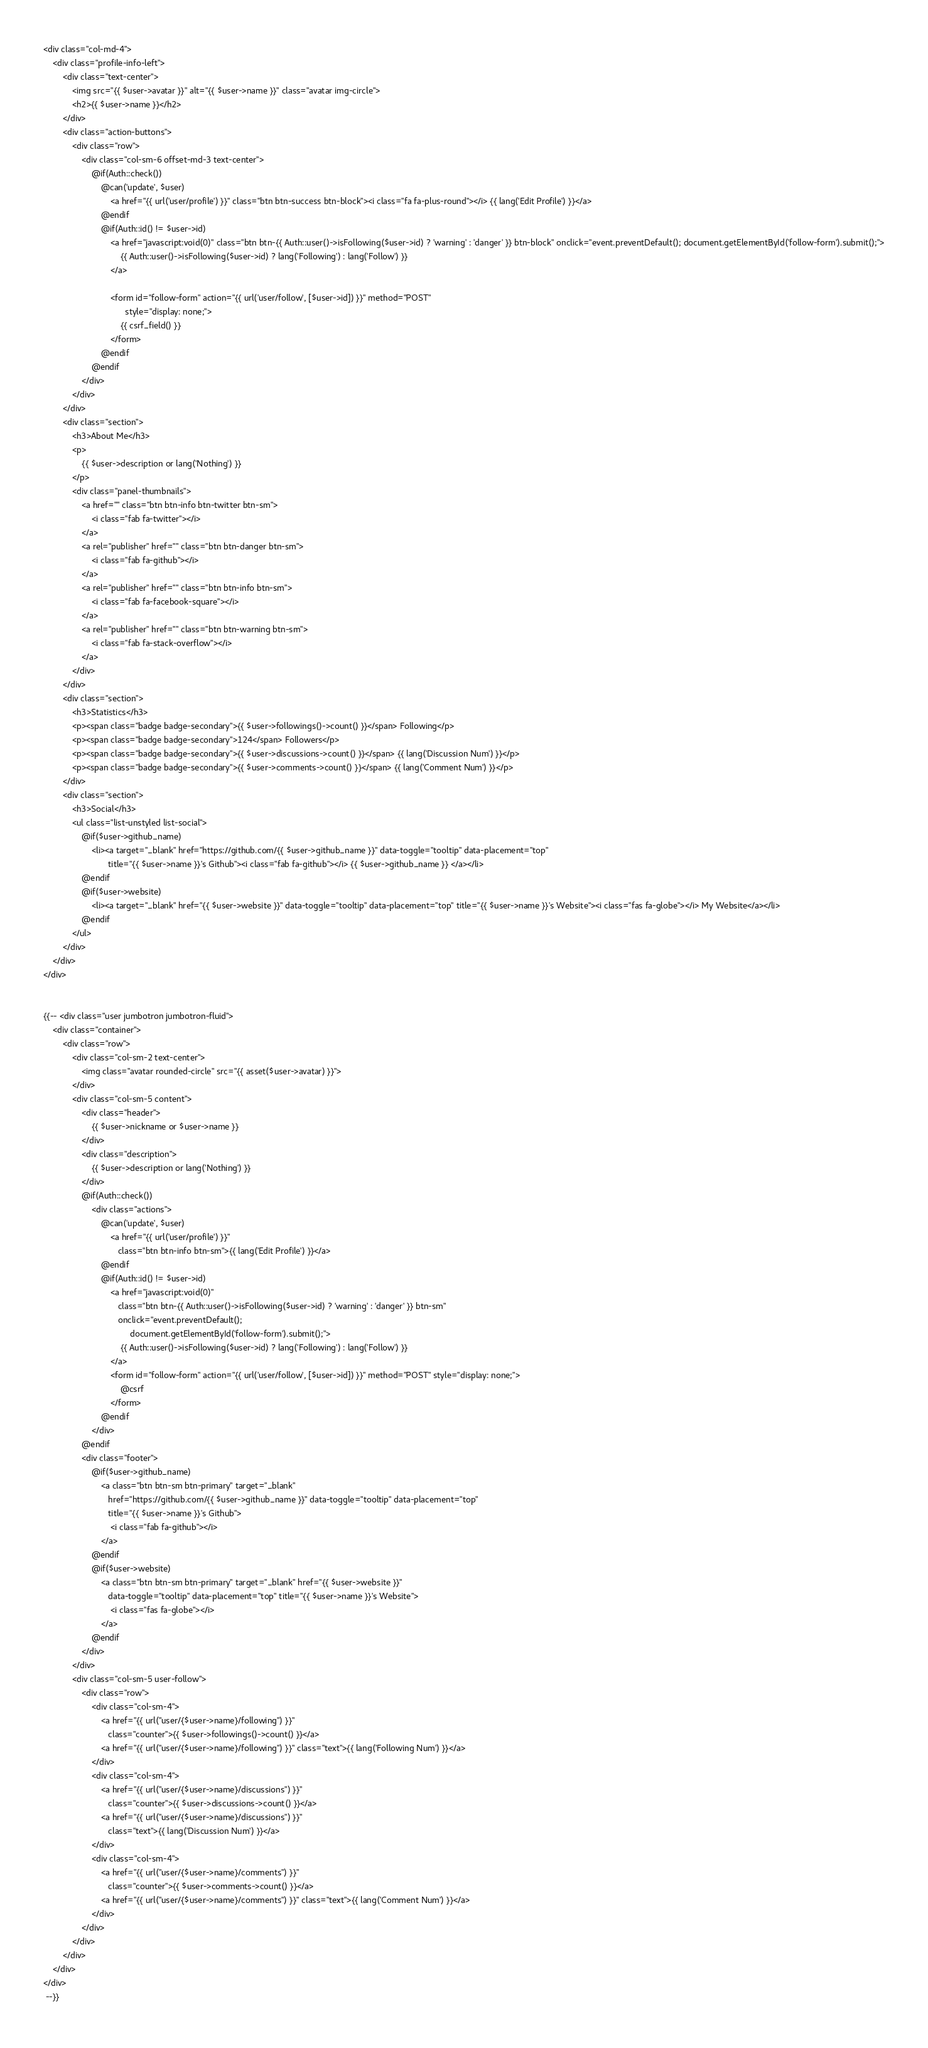<code> <loc_0><loc_0><loc_500><loc_500><_PHP_><div class="col-md-4">
    <div class="profile-info-left">
        <div class="text-center">
            <img src="{{ $user->avatar }}" alt="{{ $user->name }}" class="avatar img-circle">
            <h2>{{ $user->name }}</h2>
        </div>
        <div class="action-buttons">
            <div class="row">
                <div class="col-sm-6 offset-md-3 text-center">
                    @if(Auth::check())
                        @can('update', $user)
                            <a href="{{ url('user/profile') }}" class="btn btn-success btn-block"><i class="fa fa-plus-round"></i> {{ lang('Edit Profile') }}</a>
                        @endif
                        @if(Auth::id() != $user->id)
                            <a href="javascript:void(0)" class="btn btn-{{ Auth::user()->isFollowing($user->id) ? 'warning' : 'danger' }} btn-block" onclick="event.preventDefault(); document.getElementById('follow-form').submit();">
                                {{ Auth::user()->isFollowing($user->id) ? lang('Following') : lang('Follow') }}
                            </a>

                            <form id="follow-form" action="{{ url('user/follow', [$user->id]) }}" method="POST"
                                  style="display: none;">
                                {{ csrf_field() }}
                            </form>
                        @endif
                    @endif
                </div>
            </div>
        </div>
        <div class="section">
            <h3>About Me</h3>
            <p>
                {{ $user->description or lang('Nothing') }}
            </p>
            <div class="panel-thumbnails">
                <a href="" class="btn btn-info btn-twitter btn-sm">
                    <i class="fab fa-twitter"></i>
                </a>
                <a rel="publisher" href="" class="btn btn-danger btn-sm">
                    <i class="fab fa-github"></i>
                </a>
                <a rel="publisher" href="" class="btn btn-info btn-sm">
                    <i class="fab fa-facebook-square"></i>
                </a>
                <a rel="publisher" href="" class="btn btn-warning btn-sm">
                    <i class="fab fa-stack-overflow"></i>
                </a>
            </div>
        </div>
        <div class="section">
            <h3>Statistics</h3>
            <p><span class="badge badge-secondary">{{ $user->followings()->count() }}</span> Following</p>
            <p><span class="badge badge-secondary">124</span> Followers</p>
            <p><span class="badge badge-secondary">{{ $user->discussions->count() }}</span> {{ lang('Discussion Num') }}</p>
            <p><span class="badge badge-secondary">{{ $user->comments->count() }}</span> {{ lang('Comment Num') }}</p>
        </div>
        <div class="section">
            <h3>Social</h3>
            <ul class="list-unstyled list-social">
                @if($user->github_name)
                    <li><a target="_blank" href="https://github.com/{{ $user->github_name }}" data-toggle="tooltip" data-placement="top"
                           title="{{ $user->name }}'s Github"><i class="fab fa-github"></i> {{ $user->github_name }} </a></li>
                @endif
                @if($user->website)
                    <li><a target="_blank" href="{{ $user->website }}" data-toggle="tooltip" data-placement="top" title="{{ $user->name }}'s Website"><i class="fas fa-globe"></i> My Website</a></li>
                @endif
            </ul>
        </div>
    </div>
</div>


{{-- <div class="user jumbotron jumbotron-fluid">
    <div class="container">
        <div class="row">
            <div class="col-sm-2 text-center">
                <img class="avatar rounded-circle" src="{{ asset($user->avatar) }}">
            </div>
            <div class="col-sm-5 content">
                <div class="header">
                    {{ $user->nickname or $user->name }}
                </div>
                <div class="description">
                    {{ $user->description or lang('Nothing') }}
                </div>
                @if(Auth::check())
                    <div class="actions">
                        @can('update', $user)
                            <a href="{{ url('user/profile') }}"
                               class="btn btn-info btn-sm">{{ lang('Edit Profile') }}</a>
                        @endif
                        @if(Auth::id() != $user->id)
                            <a href="javascript:void(0)"
                               class="btn btn-{{ Auth::user()->isFollowing($user->id) ? 'warning' : 'danger' }} btn-sm"
                               onclick="event.preventDefault();
                                    document.getElementById('follow-form').submit();">
                                {{ Auth::user()->isFollowing($user->id) ? lang('Following') : lang('Follow') }}
                            </a>
                            <form id="follow-form" action="{{ url('user/follow', [$user->id]) }}" method="POST" style="display: none;">
                                @csrf
                            </form>
                        @endif
                    </div>
                @endif
                <div class="footer">
                    @if($user->github_name)
                        <a class="btn btn-sm btn-primary" target="_blank"
                           href="https://github.com/{{ $user->github_name }}" data-toggle="tooltip" data-placement="top"
                           title="{{ $user->name }}'s Github">
                            <i class="fab fa-github"></i>
                        </a>
                    @endif
                    @if($user->website)
                        <a class="btn btn-sm btn-primary" target="_blank" href="{{ $user->website }}"
                           data-toggle="tooltip" data-placement="top" title="{{ $user->name }}'s Website">
                            <i class="fas fa-globe"></i>
                        </a>
                    @endif
                </div>
            </div>
            <div class="col-sm-5 user-follow">
                <div class="row">
                    <div class="col-sm-4">
                        <a href="{{ url("user/{$user->name}/following") }}"
                           class="counter">{{ $user->followings()->count() }}</a>
                        <a href="{{ url("user/{$user->name}/following") }}" class="text">{{ lang('Following Num') }}</a>
                    </div>
                    <div class="col-sm-4">
                        <a href="{{ url("user/{$user->name}/discussions") }}"
                           class="counter">{{ $user->discussions->count() }}</a>
                        <a href="{{ url("user/{$user->name}/discussions") }}"
                           class="text">{{ lang('Discussion Num') }}</a>
                    </div>
                    <div class="col-sm-4">
                        <a href="{{ url("user/{$user->name}/comments") }}"
                           class="counter">{{ $user->comments->count() }}</a>
                        <a href="{{ url("user/{$user->name}/comments") }}" class="text">{{ lang('Comment Num') }}</a>
                    </div>
                </div>
            </div>
        </div>
    </div>
</div>
 --}}</code> 